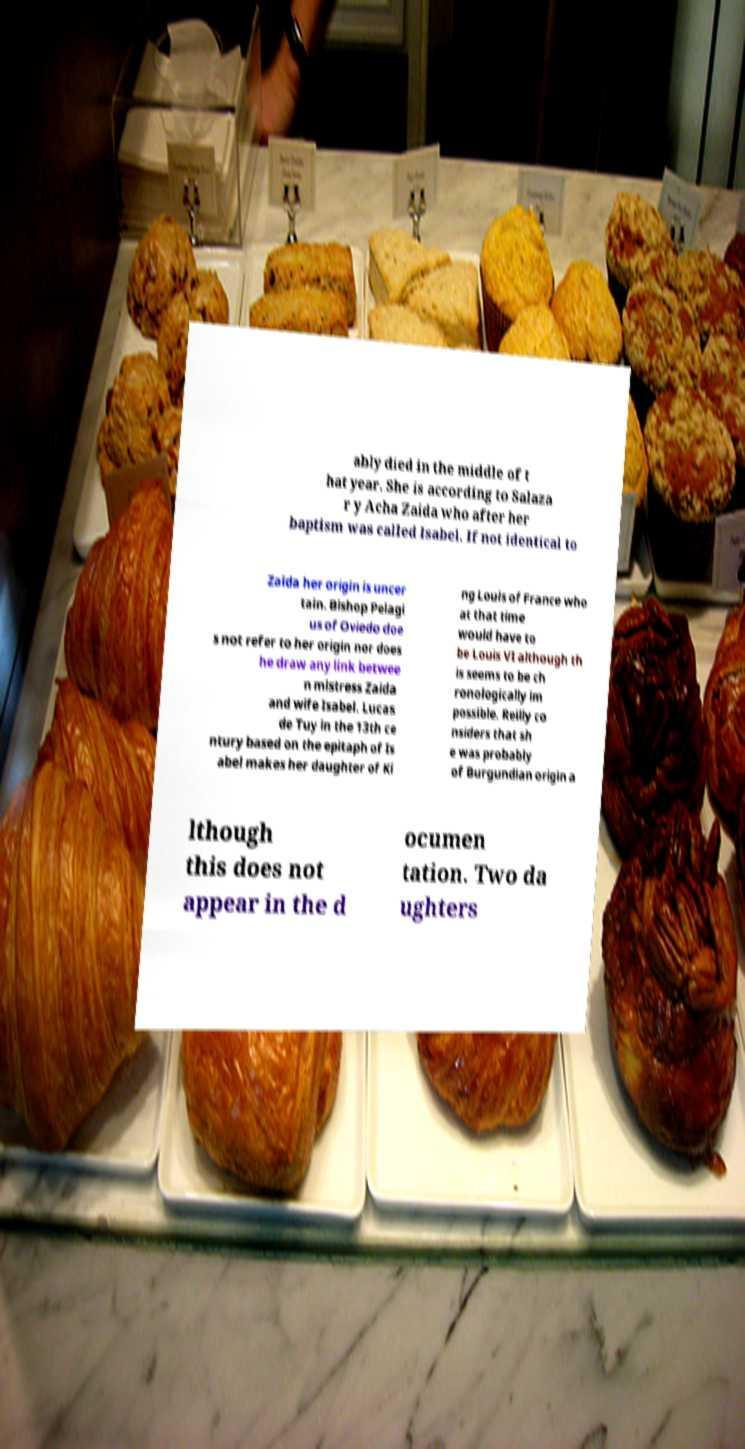Please read and relay the text visible in this image. What does it say? ably died in the middle of t hat year. She is according to Salaza r y Acha Zaida who after her baptism was called Isabel. If not identical to Zaida her origin is uncer tain. Bishop Pelagi us of Oviedo doe s not refer to her origin nor does he draw any link betwee n mistress Zaida and wife Isabel. Lucas de Tuy in the 13th ce ntury based on the epitaph of Is abel makes her daughter of Ki ng Louis of France who at that time would have to be Louis VI although th is seems to be ch ronologically im possible. Reilly co nsiders that sh e was probably of Burgundian origin a lthough this does not appear in the d ocumen tation. Two da ughters 